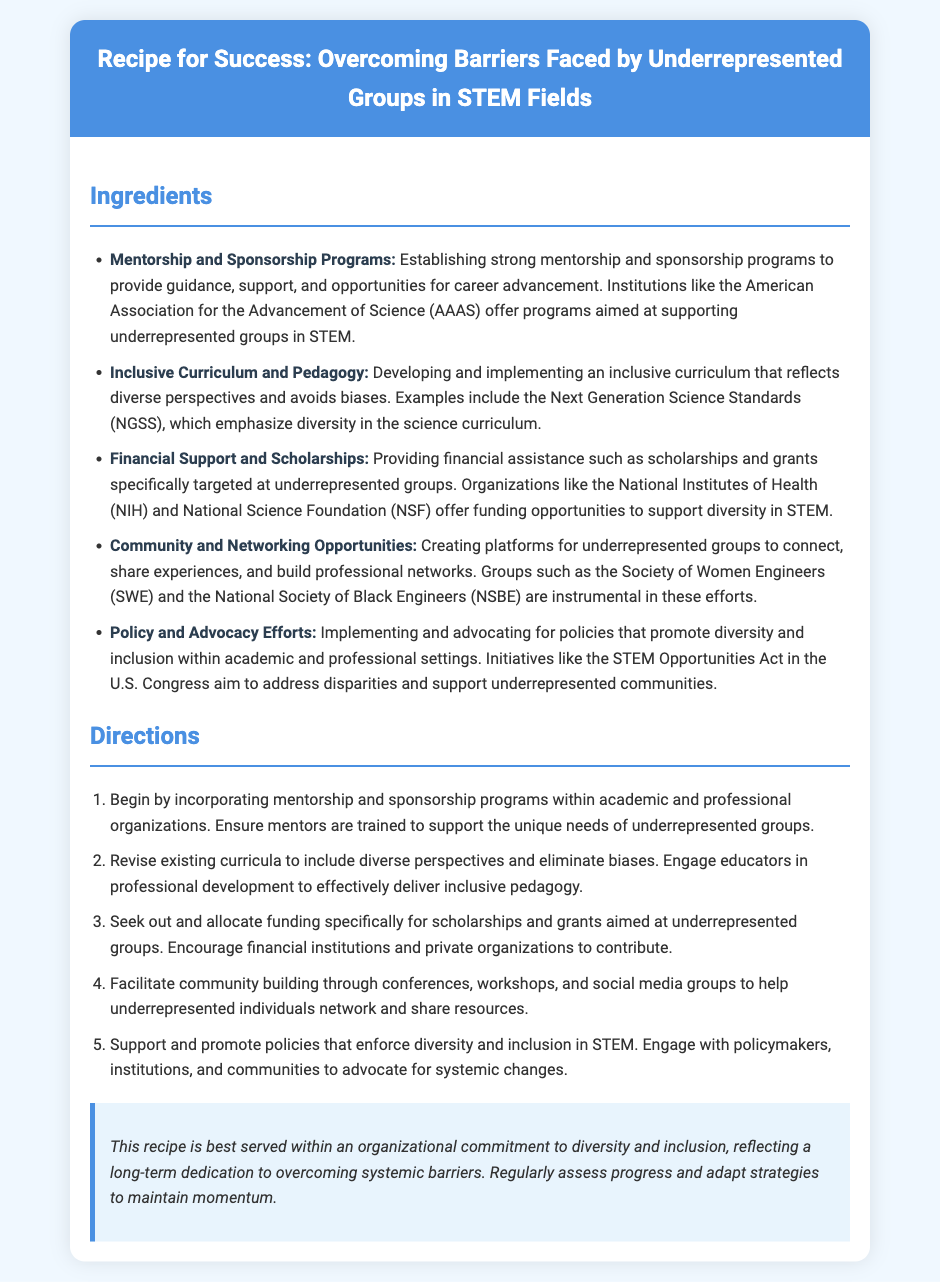What is the title of the document? The title is prominently displayed in the header section of the document.
Answer: Recipe for Success: Overcoming Barriers Faced by Underrepresented Groups in STEM Fields What is one ingredient listed that supports underrepresented groups in STEM? Ingredients are listed in the ingredients section, specifically highlighting support mechanisms.
Answer: Mentorship and Sponsorship Programs Which organization offers funding opportunities to support diversity in STEM? The document mentions organizations that provide financial assistance.
Answer: National Institutes of Health How many directions are provided in the recipe? The directions section enumerates the steps to achieve success in diversity.
Answer: Five What is an example of a community and networking opportunity mentioned? The document includes examples of organizations creating networking opportunities for underrepresented groups.
Answer: Society of Women Engineers What should be regularly assessed according to the serving suggestion? The serving suggestion provides a recommendation for maintaining the effectiveness of diversity efforts.
Answer: Progress What is emphasized within the inclusive curriculum ingredient? This ingredient highlights the importance of incorporating certain perspectives in education.
Answer: Diverse perspectives In which context should the recipe be served? The serving suggestion outlines the broader framework under which the recipe should be applied.
Answer: Organizational commitment to diversity and inclusion 